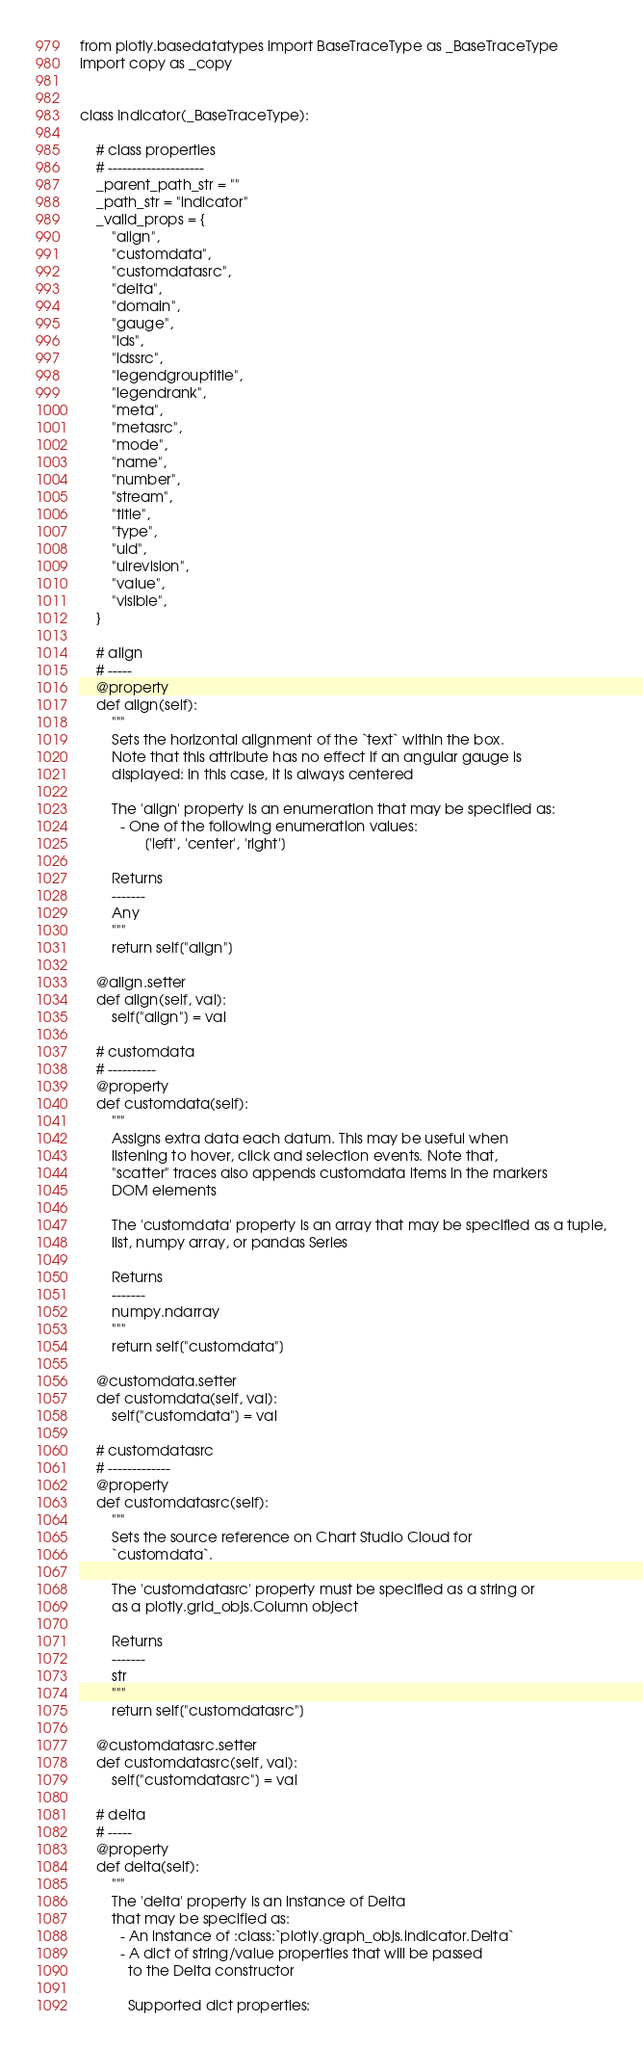<code> <loc_0><loc_0><loc_500><loc_500><_Python_>from plotly.basedatatypes import BaseTraceType as _BaseTraceType
import copy as _copy


class Indicator(_BaseTraceType):

    # class properties
    # --------------------
    _parent_path_str = ""
    _path_str = "indicator"
    _valid_props = {
        "align",
        "customdata",
        "customdatasrc",
        "delta",
        "domain",
        "gauge",
        "ids",
        "idssrc",
        "legendgrouptitle",
        "legendrank",
        "meta",
        "metasrc",
        "mode",
        "name",
        "number",
        "stream",
        "title",
        "type",
        "uid",
        "uirevision",
        "value",
        "visible",
    }

    # align
    # -----
    @property
    def align(self):
        """
        Sets the horizontal alignment of the `text` within the box.
        Note that this attribute has no effect if an angular gauge is
        displayed: in this case, it is always centered

        The 'align' property is an enumeration that may be specified as:
          - One of the following enumeration values:
                ['left', 'center', 'right']

        Returns
        -------
        Any
        """
        return self["align"]

    @align.setter
    def align(self, val):
        self["align"] = val

    # customdata
    # ----------
    @property
    def customdata(self):
        """
        Assigns extra data each datum. This may be useful when
        listening to hover, click and selection events. Note that,
        "scatter" traces also appends customdata items in the markers
        DOM elements

        The 'customdata' property is an array that may be specified as a tuple,
        list, numpy array, or pandas Series

        Returns
        -------
        numpy.ndarray
        """
        return self["customdata"]

    @customdata.setter
    def customdata(self, val):
        self["customdata"] = val

    # customdatasrc
    # -------------
    @property
    def customdatasrc(self):
        """
        Sets the source reference on Chart Studio Cloud for
        `customdata`.

        The 'customdatasrc' property must be specified as a string or
        as a plotly.grid_objs.Column object

        Returns
        -------
        str
        """
        return self["customdatasrc"]

    @customdatasrc.setter
    def customdatasrc(self, val):
        self["customdatasrc"] = val

    # delta
    # -----
    @property
    def delta(self):
        """
        The 'delta' property is an instance of Delta
        that may be specified as:
          - An instance of :class:`plotly.graph_objs.indicator.Delta`
          - A dict of string/value properties that will be passed
            to the Delta constructor

            Supported dict properties:
</code> 